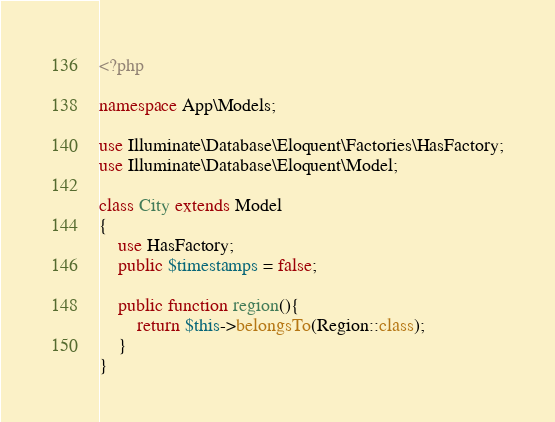<code> <loc_0><loc_0><loc_500><loc_500><_PHP_><?php

namespace App\Models;

use Illuminate\Database\Eloquent\Factories\HasFactory;
use Illuminate\Database\Eloquent\Model;

class City extends Model
{
    use HasFactory;
    public $timestamps = false;

    public function region(){
        return $this->belongsTo(Region::class);
    }
}
</code> 